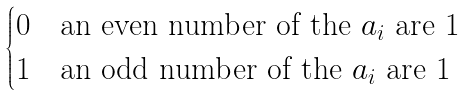Convert formula to latex. <formula><loc_0><loc_0><loc_500><loc_500>\begin{cases} 0 & \text {an even number of the $a_{i}$ are $1$} \\ 1 & \text {an odd number of the $a_{i}$ are $1$} \end{cases}</formula> 